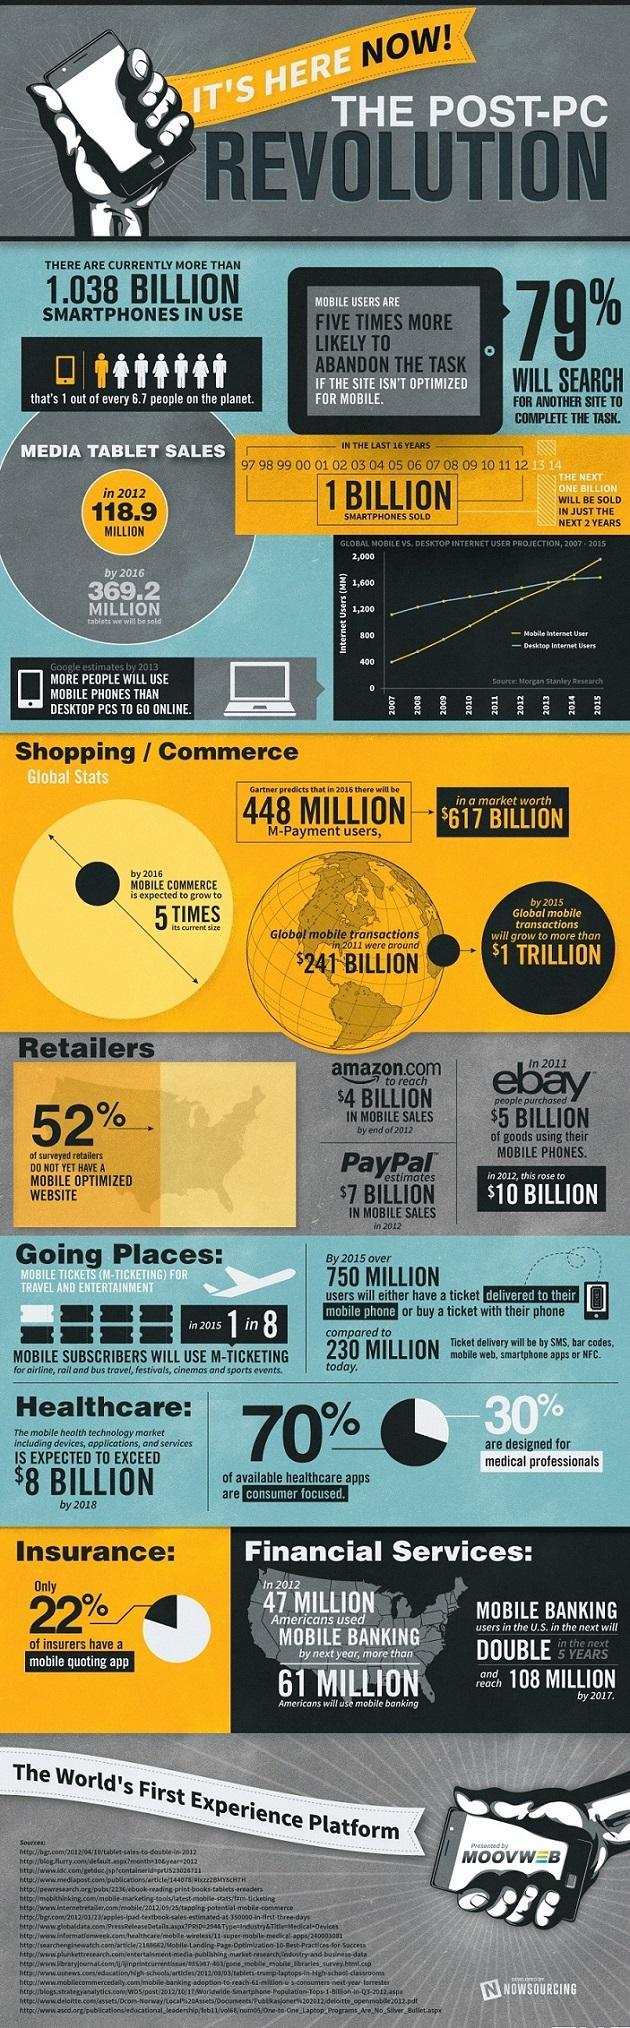Outline some significant characteristics in this image. According to the survey, 21% of respondents stated that they would not search for another site to complete the task. According to a survey of retailers, 48% have a mobile-optimized website. 